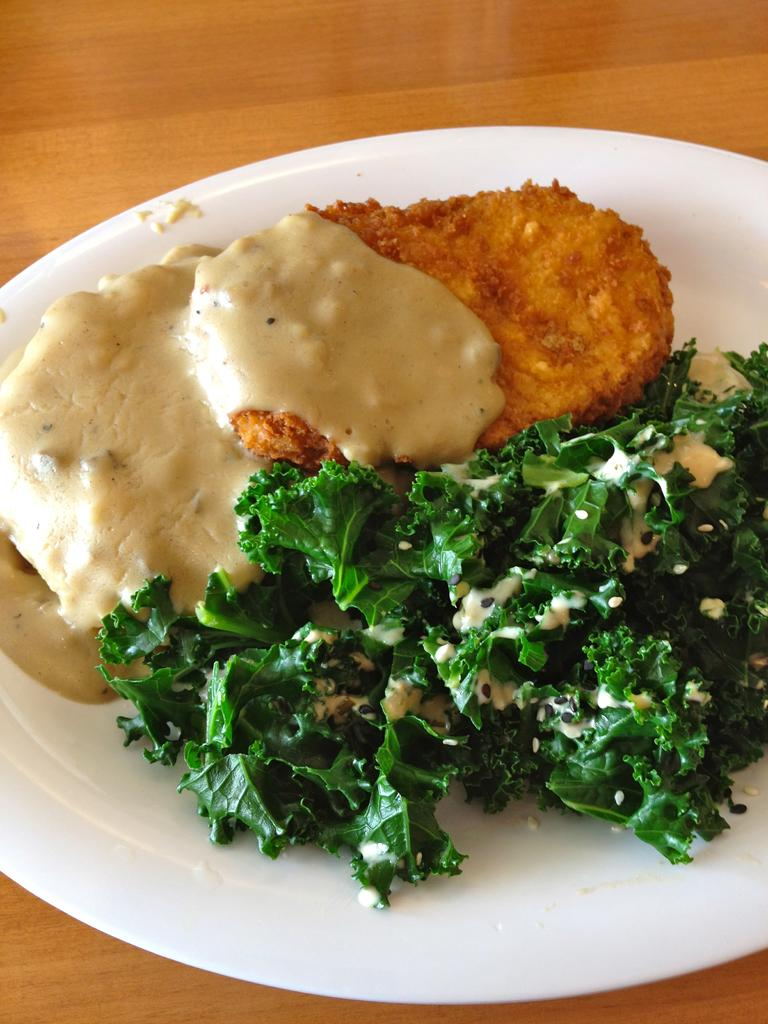What is on the plate that is visible in the image? There is food on a plate in the image. Where is the plate located in the image? The plate is placed on a table. What type of vegetable can be seen growing in the grass in the image? There is no vegetable or grass present in the image; it only shows a plate with food on a table. 